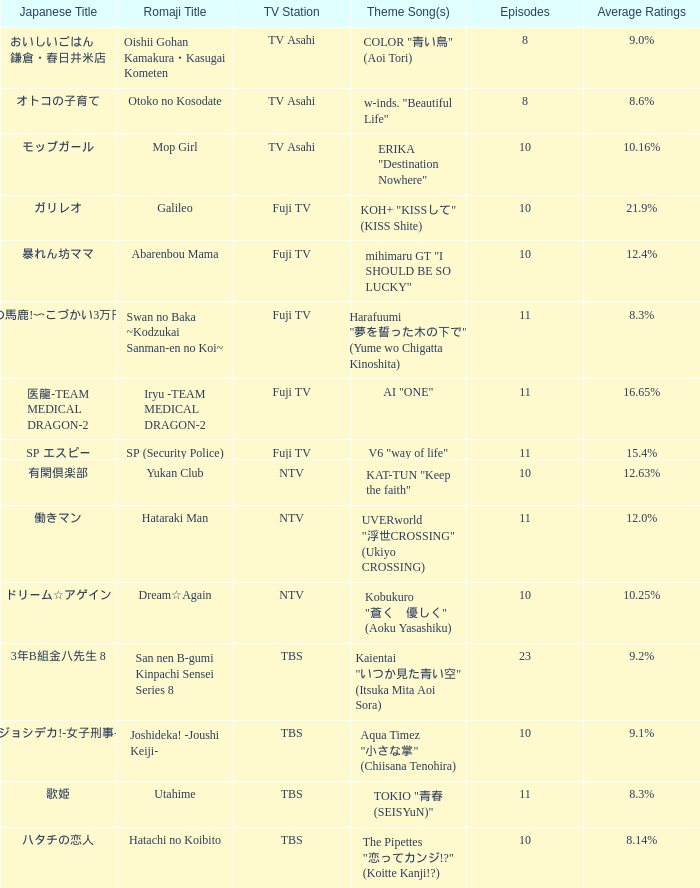Write the full table. {'header': ['Japanese Title', 'Romaji Title', 'TV Station', 'Theme Song(s)', 'Episodes', 'Average Ratings'], 'rows': [['おいしいごはん 鎌倉・春日井米店', 'Oishii Gohan Kamakura・Kasugai Kometen', 'TV Asahi', 'COLOR "青い鳥" (Aoi Tori)', '8', '9.0%'], ['オトコの子育て', 'Otoko no Kosodate', 'TV Asahi', 'w-inds. "Beautiful Life"', '8', '8.6%'], ['モップガール', 'Mop Girl', 'TV Asahi', 'ERIKA "Destination Nowhere"', '10', '10.16%'], ['ガリレオ', 'Galileo', 'Fuji TV', 'KOH+ "KISSして" (KISS Shite)', '10', '21.9%'], ['暴れん坊ママ', 'Abarenbou Mama', 'Fuji TV', 'mihimaru GT "I SHOULD BE SO LUCKY"', '10', '12.4%'], ['スワンの馬鹿!〜こづかい3万円の恋〜', 'Swan no Baka ~Kodzukai Sanman-en no Koi~', 'Fuji TV', 'Harafuumi "夢を誓った木の下で" (Yume wo Chigatta Kinoshita)', '11', '8.3%'], ['医龍-TEAM MEDICAL DRAGON-2', 'Iryu -TEAM MEDICAL DRAGON-2', 'Fuji TV', 'AI "ONE"', '11', '16.65%'], ['SP エスピー', 'SP (Security Police)', 'Fuji TV', 'V6 "way of life"', '11', '15.4%'], ['有閑倶楽部', 'Yukan Club', 'NTV', 'KAT-TUN "Keep the faith"', '10', '12.63%'], ['働きマン', 'Hataraki Man', 'NTV', 'UVERworld "浮世CROSSING" (Ukiyo CROSSING)', '11', '12.0%'], ['ドリーム☆アゲイン', 'Dream☆Again', 'NTV', 'Kobukuro "蒼く\u3000優しく" (Aoku Yasashiku)', '10', '10.25%'], ['3年B組金八先生 8', 'San nen B-gumi Kinpachi Sensei Series 8', 'TBS', 'Kaientai "いつか見た青い空" (Itsuka Mita Aoi Sora)', '23', '9.2%'], ['ジョシデカ!-女子刑事-', 'Joshideka! -Joushi Keiji-', 'TBS', 'Aqua Timez "小さな掌" (Chiisana Tenohira)', '10', '9.1%'], ['歌姫', 'Utahime', 'TBS', 'TOKIO "青春 (SEISYuN)"', '11', '8.3%'], ['ハタチの恋人', 'Hatachi no Koibito', 'TBS', 'The Pipettes "恋ってカンジ!?" (Koitte Kanji!?)', '10', '8.14%']]} What is the main song of the series on fuji tv station with median ratings of 1 AI "ONE". 